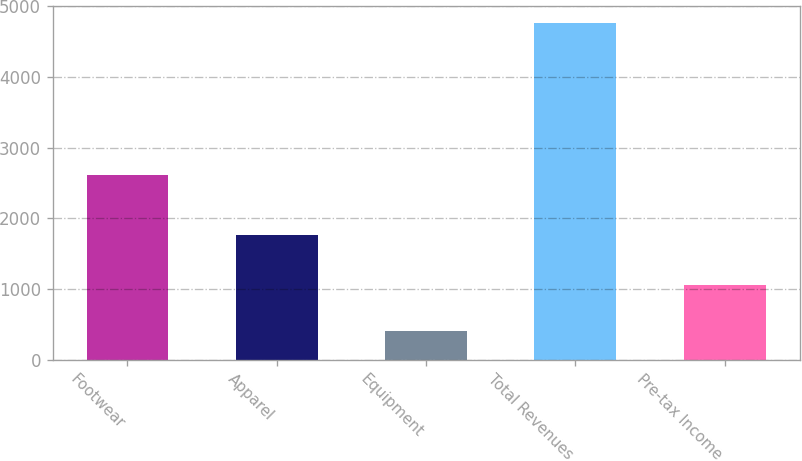Convert chart to OTSL. <chart><loc_0><loc_0><loc_500><loc_500><bar_chart><fcel>Footwear<fcel>Apparel<fcel>Equipment<fcel>Total Revenues<fcel>Pre-tax Income<nl><fcel>2608<fcel>1757.2<fcel>398.9<fcel>4764.1<fcel>1050.1<nl></chart> 